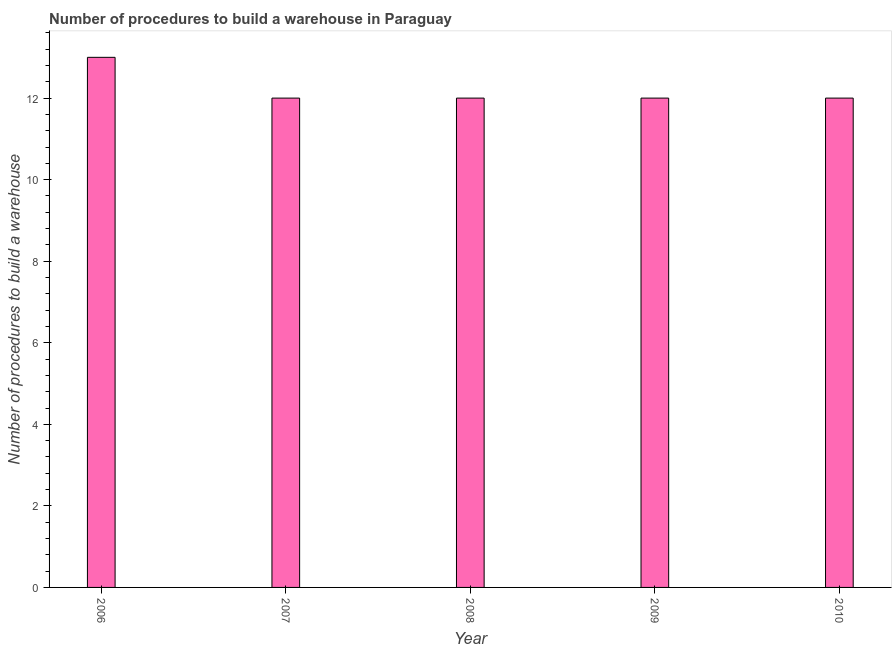Does the graph contain any zero values?
Give a very brief answer. No. Does the graph contain grids?
Your answer should be compact. No. What is the title of the graph?
Keep it short and to the point. Number of procedures to build a warehouse in Paraguay. What is the label or title of the Y-axis?
Your answer should be compact. Number of procedures to build a warehouse. Across all years, what is the maximum number of procedures to build a warehouse?
Keep it short and to the point. 13. In which year was the number of procedures to build a warehouse maximum?
Provide a short and direct response. 2006. What is the average number of procedures to build a warehouse per year?
Offer a very short reply. 12. What is the median number of procedures to build a warehouse?
Your answer should be compact. 12. In how many years, is the number of procedures to build a warehouse greater than 5.6 ?
Keep it short and to the point. 5. What is the ratio of the number of procedures to build a warehouse in 2006 to that in 2008?
Your answer should be compact. 1.08. Is the difference between the number of procedures to build a warehouse in 2007 and 2009 greater than the difference between any two years?
Offer a very short reply. No. Is the sum of the number of procedures to build a warehouse in 2009 and 2010 greater than the maximum number of procedures to build a warehouse across all years?
Keep it short and to the point. Yes. How many years are there in the graph?
Your answer should be very brief. 5. What is the difference between two consecutive major ticks on the Y-axis?
Make the answer very short. 2. What is the difference between the Number of procedures to build a warehouse in 2006 and 2007?
Keep it short and to the point. 1. What is the difference between the Number of procedures to build a warehouse in 2006 and 2008?
Keep it short and to the point. 1. What is the difference between the Number of procedures to build a warehouse in 2006 and 2009?
Ensure brevity in your answer.  1. What is the difference between the Number of procedures to build a warehouse in 2006 and 2010?
Make the answer very short. 1. What is the difference between the Number of procedures to build a warehouse in 2007 and 2008?
Give a very brief answer. 0. What is the difference between the Number of procedures to build a warehouse in 2007 and 2009?
Provide a succinct answer. 0. What is the difference between the Number of procedures to build a warehouse in 2009 and 2010?
Your answer should be very brief. 0. What is the ratio of the Number of procedures to build a warehouse in 2006 to that in 2007?
Your answer should be compact. 1.08. What is the ratio of the Number of procedures to build a warehouse in 2006 to that in 2008?
Your response must be concise. 1.08. What is the ratio of the Number of procedures to build a warehouse in 2006 to that in 2009?
Offer a very short reply. 1.08. What is the ratio of the Number of procedures to build a warehouse in 2006 to that in 2010?
Your answer should be compact. 1.08. What is the ratio of the Number of procedures to build a warehouse in 2008 to that in 2009?
Offer a terse response. 1. 